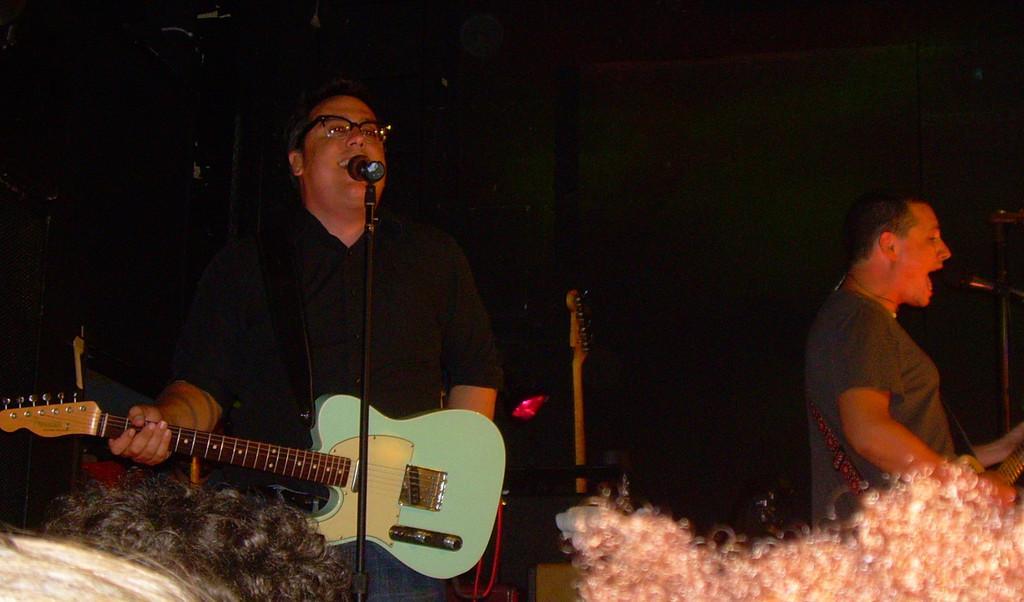Please provide a concise description of this image. In this image i can see a person holding a guitar and there is a microphone in front of him. In the background i can see another person standing and holding a musical instrument. 